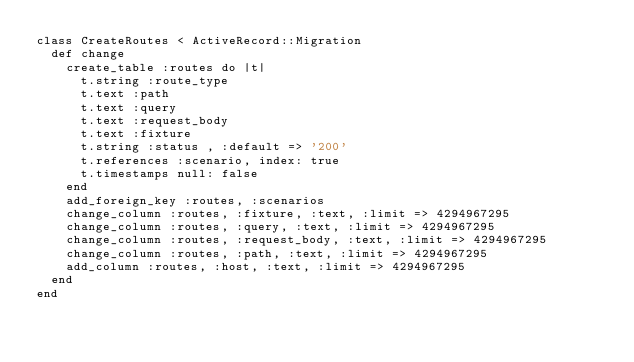<code> <loc_0><loc_0><loc_500><loc_500><_Ruby_>class CreateRoutes < ActiveRecord::Migration
  def change
    create_table :routes do |t|
      t.string :route_type
      t.text :path
      t.text :query
      t.text :request_body
      t.text :fixture
      t.string :status , :default => '200'
      t.references :scenario, index: true
      t.timestamps null: false
    end
    add_foreign_key :routes, :scenarios
    change_column :routes, :fixture, :text, :limit => 4294967295
    change_column :routes, :query, :text, :limit => 4294967295
    change_column :routes, :request_body, :text, :limit => 4294967295
    change_column :routes, :path, :text, :limit => 4294967295
    add_column :routes, :host, :text, :limit => 4294967295
  end
end
</code> 